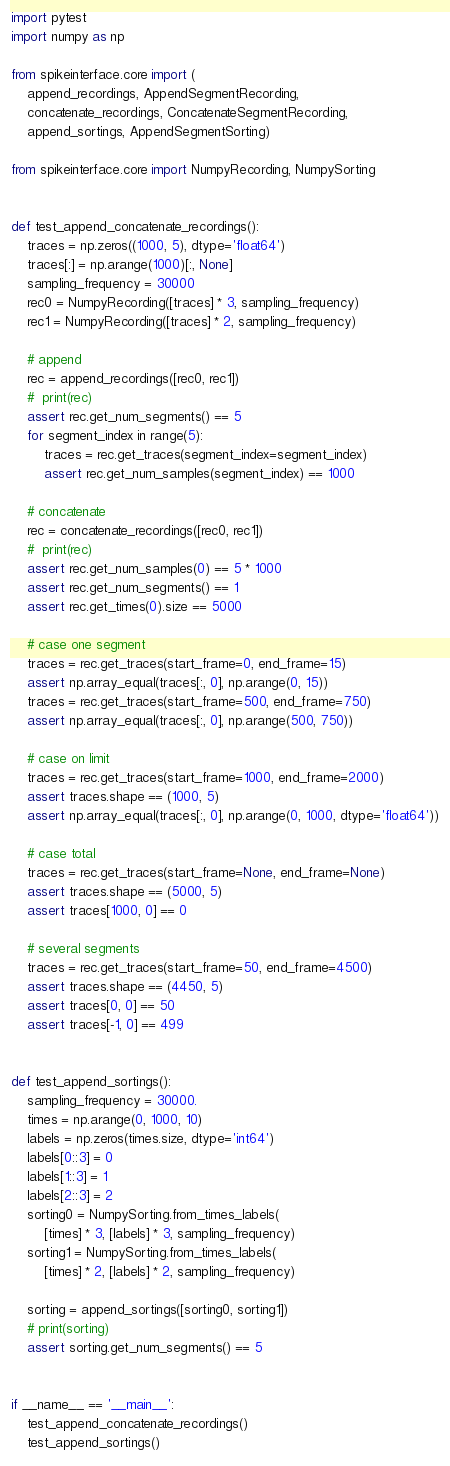<code> <loc_0><loc_0><loc_500><loc_500><_Python_>import pytest
import numpy as np

from spikeinterface.core import (
    append_recordings, AppendSegmentRecording,
    concatenate_recordings, ConcatenateSegmentRecording,
    append_sortings, AppendSegmentSorting)

from spikeinterface.core import NumpyRecording, NumpySorting


def test_append_concatenate_recordings():
    traces = np.zeros((1000, 5), dtype='float64')
    traces[:] = np.arange(1000)[:, None]
    sampling_frequency = 30000
    rec0 = NumpyRecording([traces] * 3, sampling_frequency)
    rec1 = NumpyRecording([traces] * 2, sampling_frequency)

    # append
    rec = append_recordings([rec0, rec1])
    #  print(rec)
    assert rec.get_num_segments() == 5
    for segment_index in range(5):
        traces = rec.get_traces(segment_index=segment_index)
        assert rec.get_num_samples(segment_index) == 1000

    # concatenate
    rec = concatenate_recordings([rec0, rec1])
    #  print(rec)
    assert rec.get_num_samples(0) == 5 * 1000
    assert rec.get_num_segments() == 1
    assert rec.get_times(0).size == 5000

    # case one segment
    traces = rec.get_traces(start_frame=0, end_frame=15)
    assert np.array_equal(traces[:, 0], np.arange(0, 15))
    traces = rec.get_traces(start_frame=500, end_frame=750)
    assert np.array_equal(traces[:, 0], np.arange(500, 750))

    # case on limit
    traces = rec.get_traces(start_frame=1000, end_frame=2000)
    assert traces.shape == (1000, 5)
    assert np.array_equal(traces[:, 0], np.arange(0, 1000, dtype='float64'))

    # case total
    traces = rec.get_traces(start_frame=None, end_frame=None)
    assert traces.shape == (5000, 5)
    assert traces[1000, 0] == 0

    # several segments
    traces = rec.get_traces(start_frame=50, end_frame=4500)
    assert traces.shape == (4450, 5)
    assert traces[0, 0] == 50
    assert traces[-1, 0] == 499


def test_append_sortings():
    sampling_frequency = 30000.
    times = np.arange(0, 1000, 10)
    labels = np.zeros(times.size, dtype='int64')
    labels[0::3] = 0
    labels[1::3] = 1
    labels[2::3] = 2
    sorting0 = NumpySorting.from_times_labels(
        [times] * 3, [labels] * 3, sampling_frequency)
    sorting1 = NumpySorting.from_times_labels(
        [times] * 2, [labels] * 2, sampling_frequency)

    sorting = append_sortings([sorting0, sorting1])
    # print(sorting)
    assert sorting.get_num_segments() == 5


if __name__ == '__main__':
    test_append_concatenate_recordings()
    test_append_sortings()
</code> 